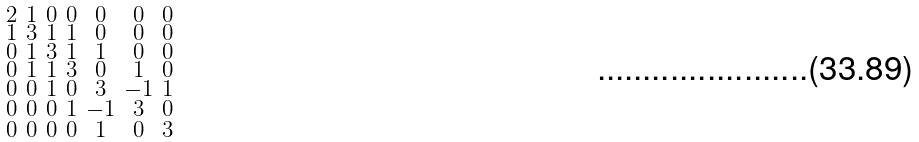<formula> <loc_0><loc_0><loc_500><loc_500>\begin{smallmatrix} 2 & 1 & 0 & 0 & 0 & 0 & 0 \\ 1 & 3 & 1 & 1 & 0 & 0 & 0 \\ 0 & 1 & 3 & 1 & 1 & 0 & 0 \\ 0 & 1 & 1 & 3 & 0 & 1 & 0 \\ 0 & 0 & 1 & 0 & 3 & - 1 & 1 \\ 0 & 0 & 0 & 1 & - 1 & 3 & 0 \\ 0 & 0 & 0 & 0 & 1 & 0 & 3 \end{smallmatrix}</formula> 